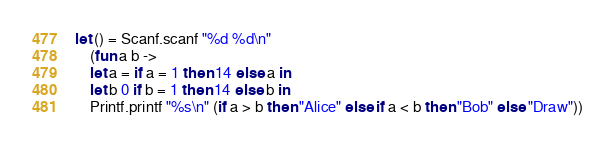<code> <loc_0><loc_0><loc_500><loc_500><_OCaml_>let () = Scanf.scanf "%d %d\n" 
	(fun a b -> 
    let a = if a = 1 then 14 else a in
    let b 0 if b = 1 then 14 else b in
    Printf.printf "%s\n" (if a > b then "Alice" else if a < b then "Bob" else "Draw"))</code> 